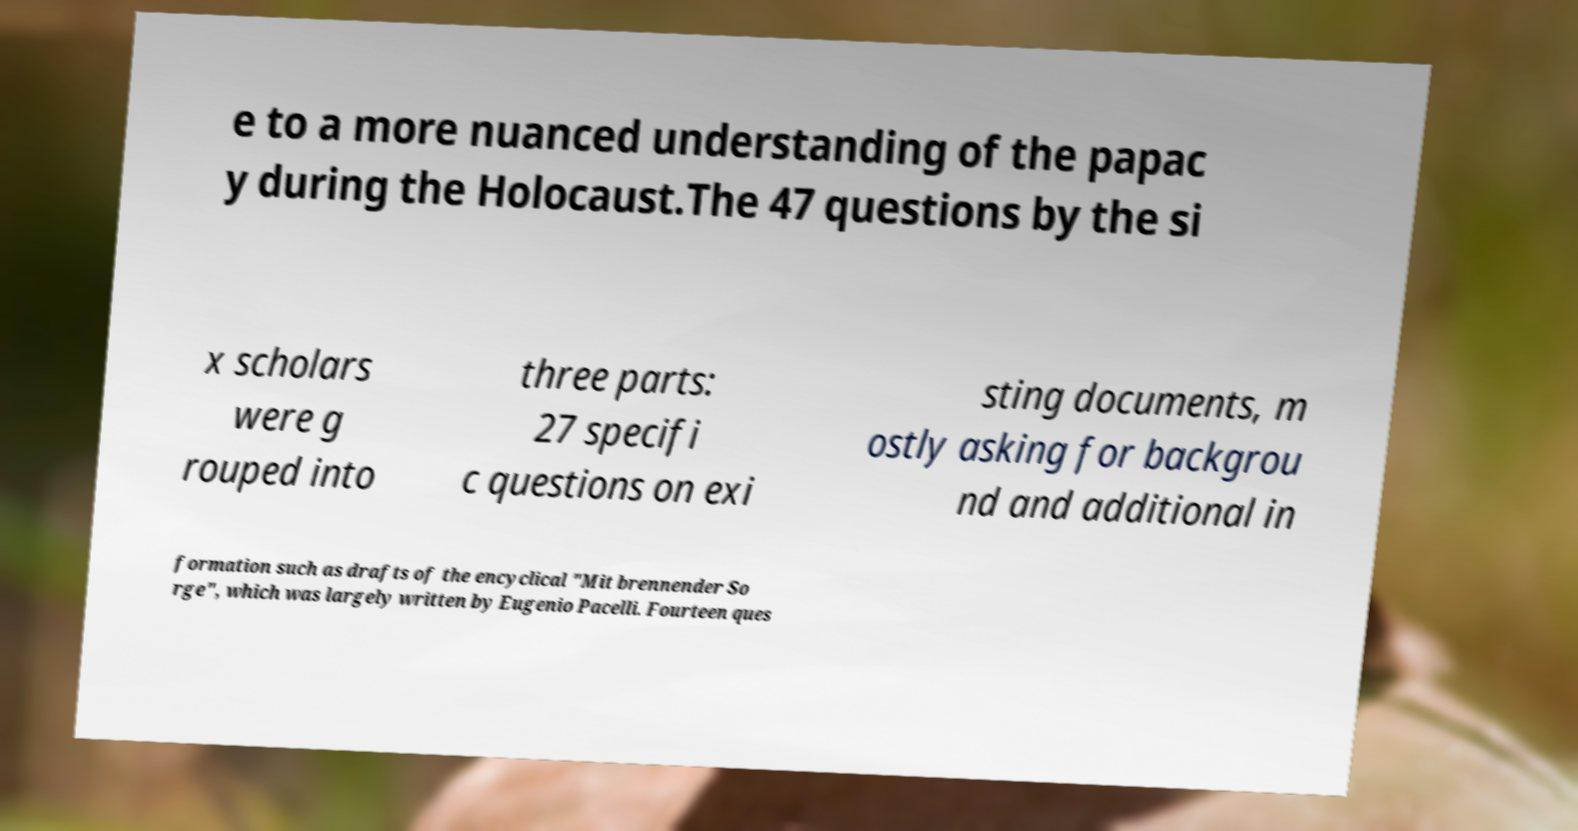Could you assist in decoding the text presented in this image and type it out clearly? e to a more nuanced understanding of the papac y during the Holocaust.The 47 questions by the si x scholars were g rouped into three parts: 27 specifi c questions on exi sting documents, m ostly asking for backgrou nd and additional in formation such as drafts of the encyclical "Mit brennender So rge", which was largely written by Eugenio Pacelli. Fourteen ques 